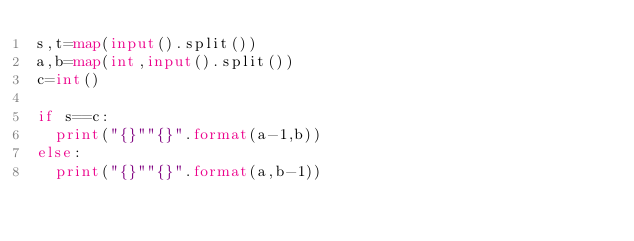Convert code to text. <code><loc_0><loc_0><loc_500><loc_500><_Python_>s,t=map(input().split())
a,b=map(int,input().split())
c=int()

if s==c:
  print("{}""{}".format(a-1,b))
else:
  print("{}""{}".format(a,b-1))</code> 